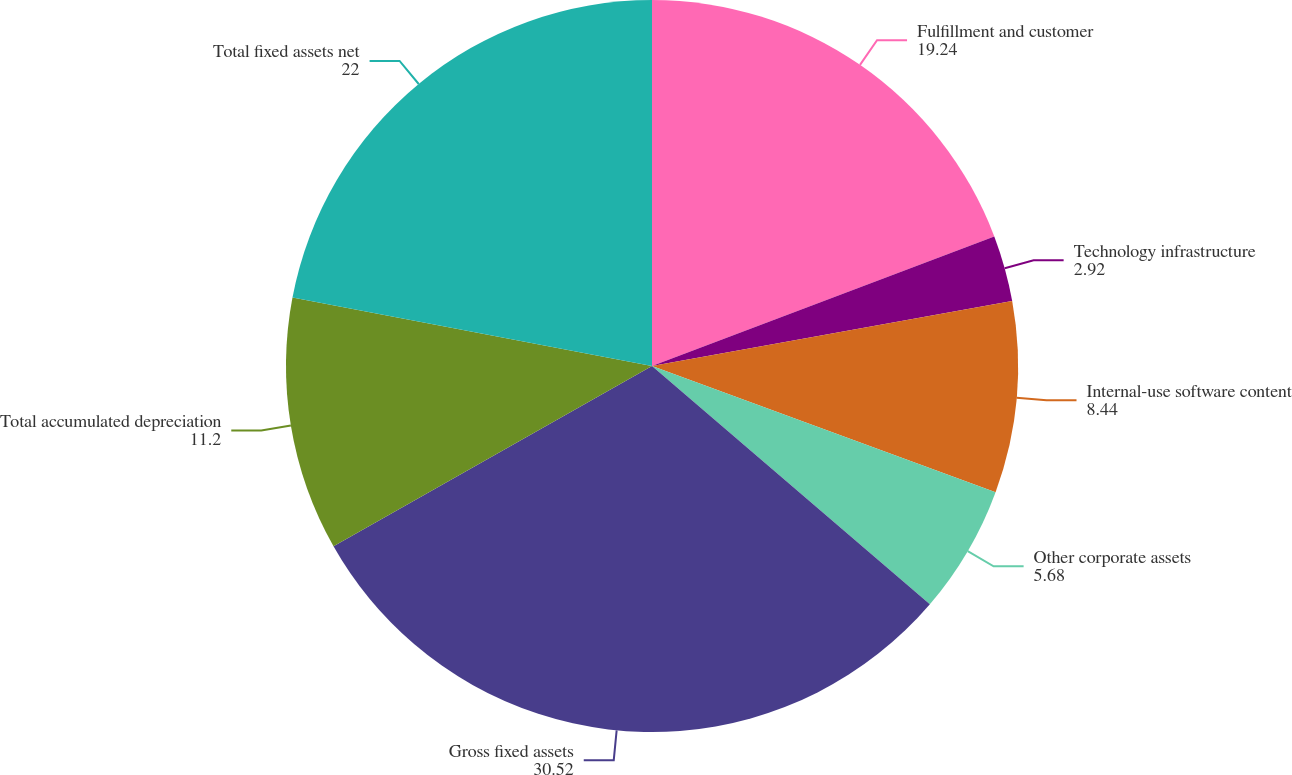Convert chart. <chart><loc_0><loc_0><loc_500><loc_500><pie_chart><fcel>Fulfillment and customer<fcel>Technology infrastructure<fcel>Internal-use software content<fcel>Other corporate assets<fcel>Gross fixed assets<fcel>Total accumulated depreciation<fcel>Total fixed assets net<nl><fcel>19.24%<fcel>2.92%<fcel>8.44%<fcel>5.68%<fcel>30.52%<fcel>11.2%<fcel>22.0%<nl></chart> 